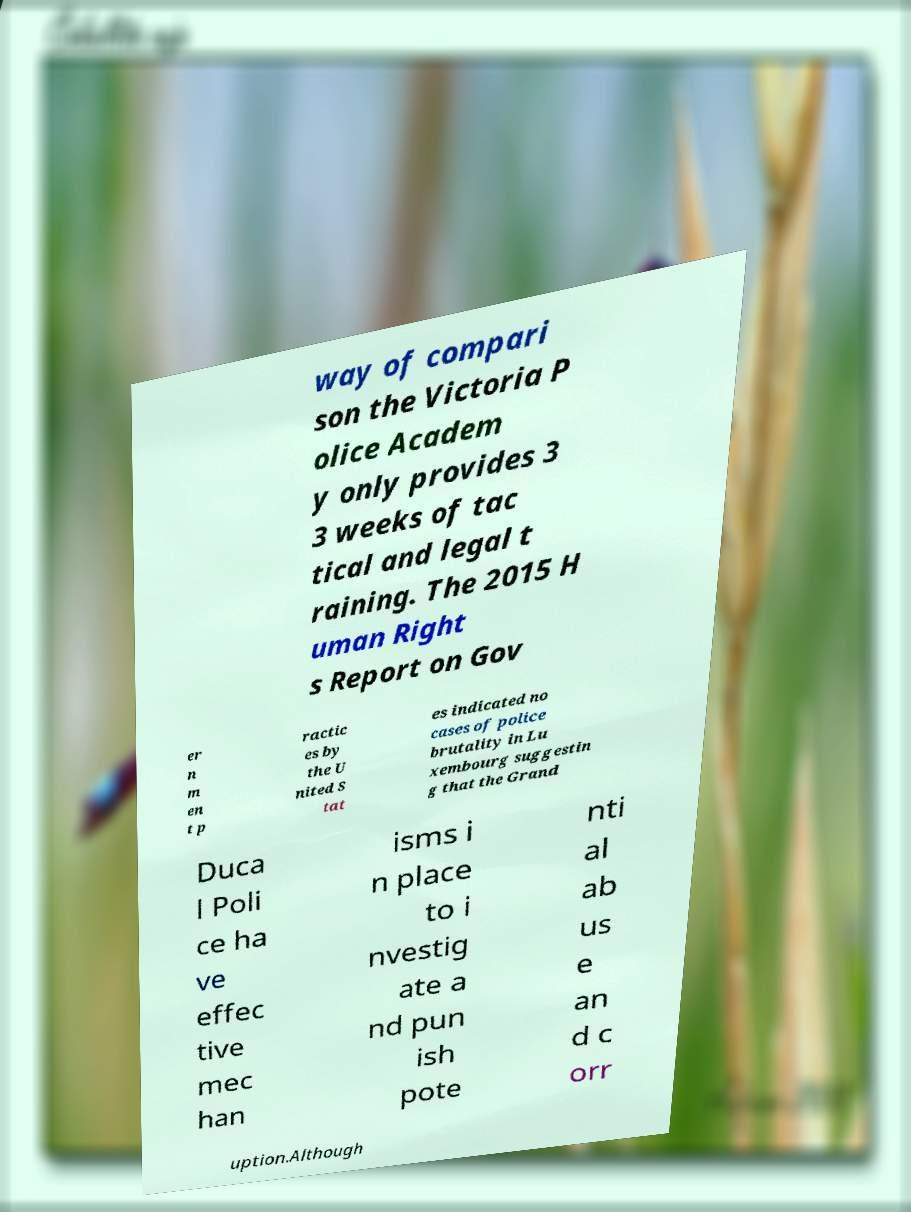For documentation purposes, I need the text within this image transcribed. Could you provide that? way of compari son the Victoria P olice Academ y only provides 3 3 weeks of tac tical and legal t raining. The 2015 H uman Right s Report on Gov er n m en t p ractic es by the U nited S tat es indicated no cases of police brutality in Lu xembourg suggestin g that the Grand Duca l Poli ce ha ve effec tive mec han isms i n place to i nvestig ate a nd pun ish pote nti al ab us e an d c orr uption.Although 